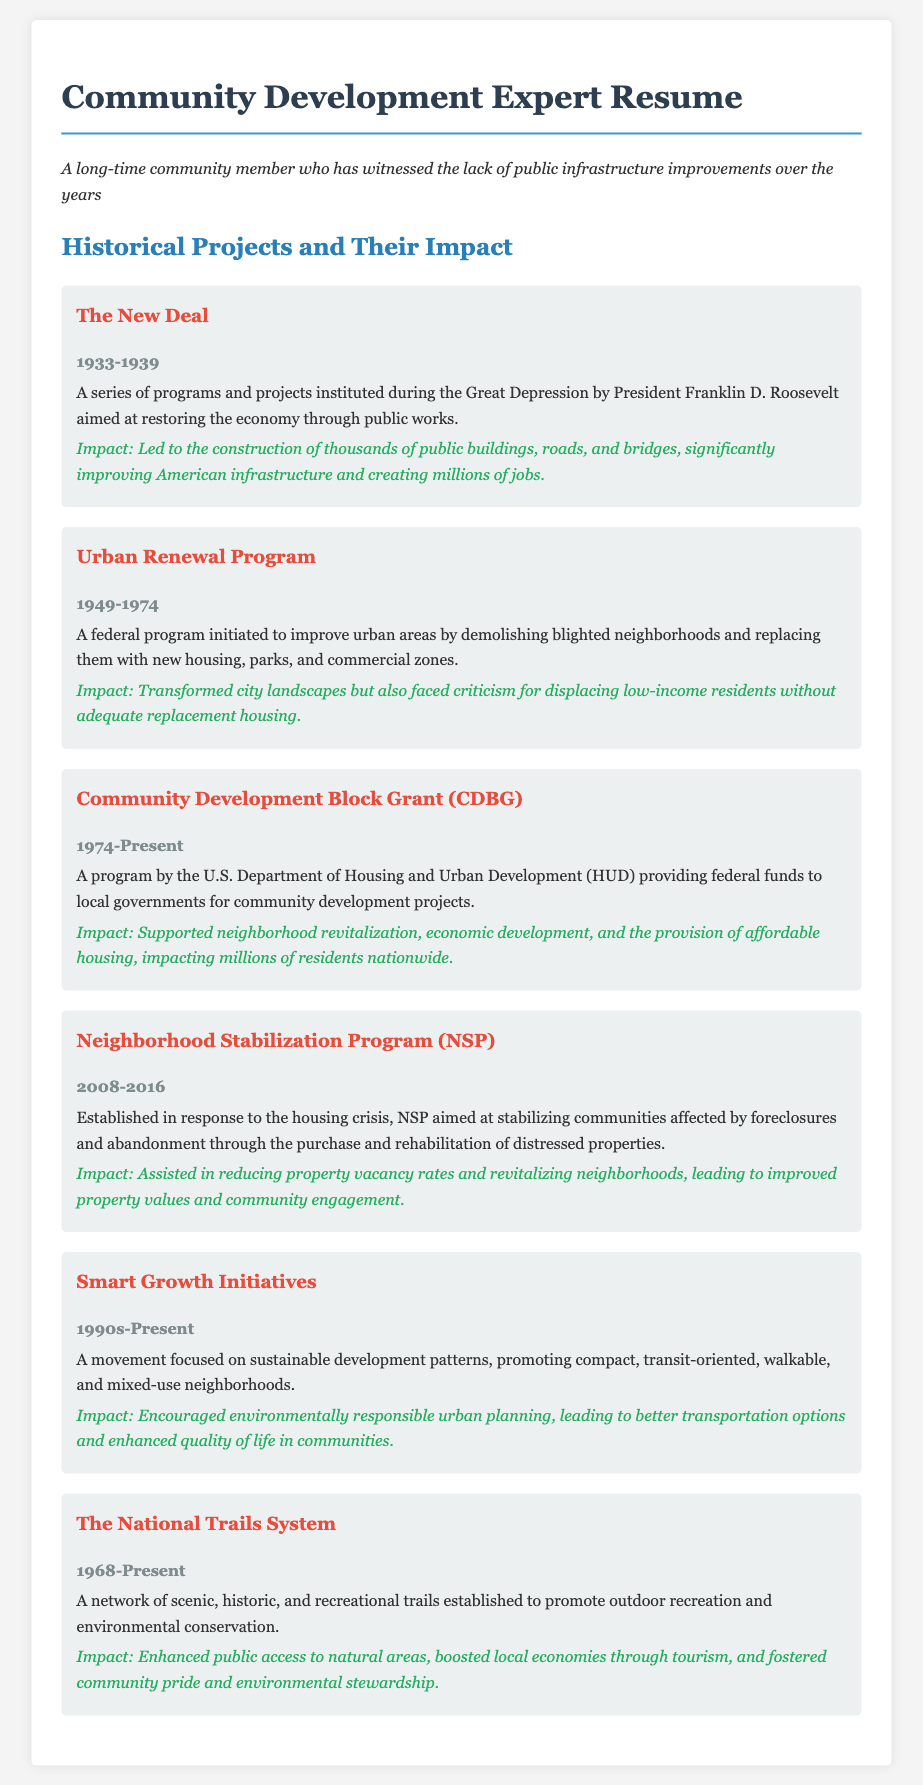What was the duration of The New Deal? The duration is mentioned as the years it was active, which is from 1933 to 1939.
Answer: 1933-1939 What was the main goal of the Urban Renewal Program? The main goal was to improve urban areas by demolishing blighted neighborhoods and replacing them.
Answer: Improve urban areas What is the CDBG program associated with? The CDBG program is associated with providing federal funds to local governments for community development projects.
Answer: Federal funds for community development What initiative was established in response to the housing crisis? The Neighborhood Stabilization Program (NSP) was established in response to the housing crisis.
Answer: Neighborhood Stabilization Program (NSP) What is the focus of Smart Growth Initiatives? The focus is on sustainable development patterns and promoting compact, transit-oriented neighborhoods.
Answer: Sustainable development patterns How long has The National Trails System been established? The National Trails System has been established since 1968 and is still active.
Answer: 1968-Present What impact did the New Deal have on American infrastructure? The impact included the construction of thousands of public buildings, roads, and bridges, and job creation.
Answer: Thousands of public buildings, roads, and bridges What criticism did the Urban Renewal Program face? The criticism was primarily about displacing low-income residents without adequate replacement housing.
Answer: Displacing low-income residents What is one impact of the Community Development Block Grant? One impact is the support of neighborhood revitalization and economic development.
Answer: Neighborhood revitalization and economic development 